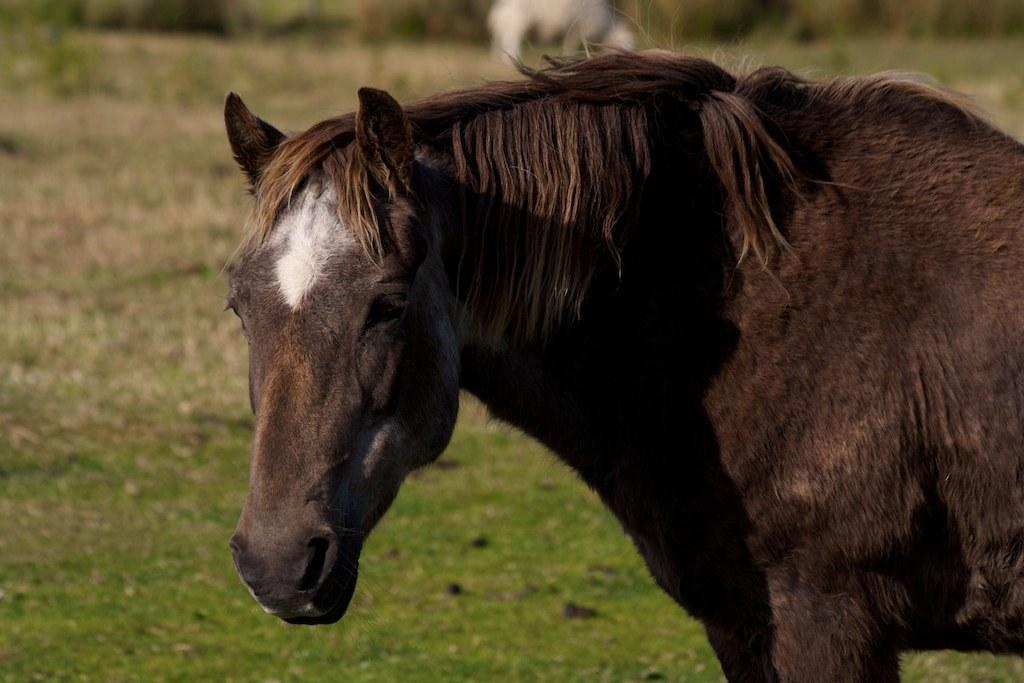What animal is the main subject of the image? There is a horse in the image. Where is the horse located? The horse is on a field. What is the field covered with? The field is covered with grass. What can be seen in the distance beyond the field? There are plants and other animals visible in the distance. What scientific theory is being discussed by the horse in the image? There is no indication in the image that the horse is discussing any scientific theories. Who is the expert on horse care in the image? There is no expert on horse care present in the image; it simply features a horse on a field. 